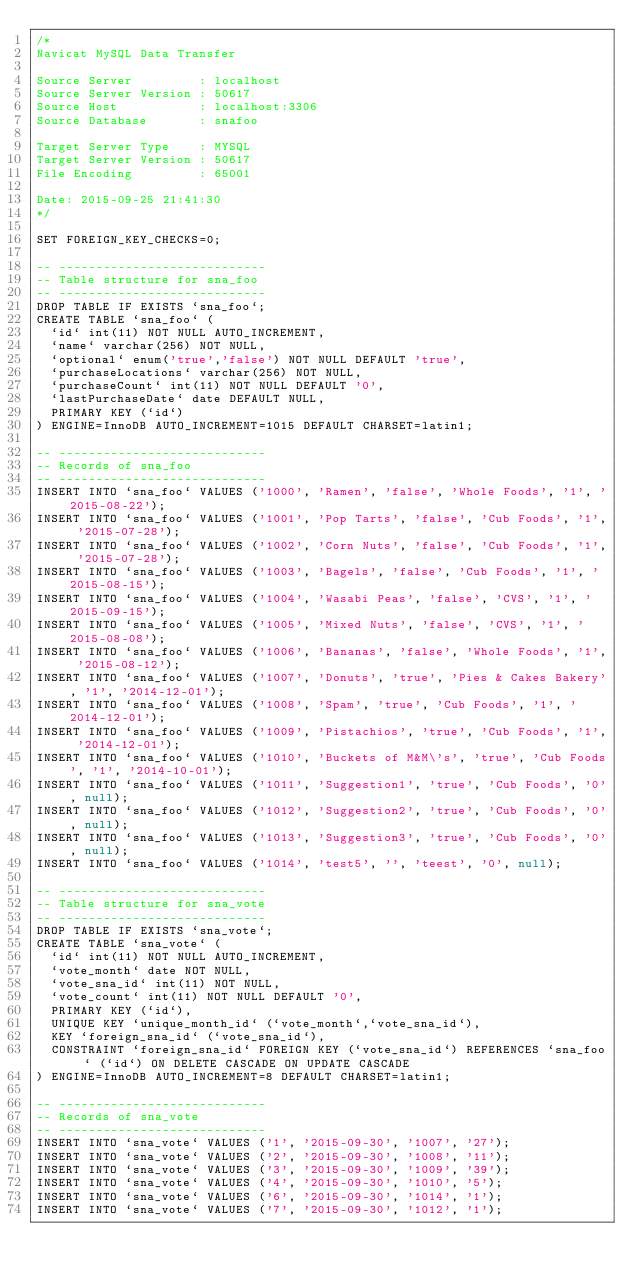Convert code to text. <code><loc_0><loc_0><loc_500><loc_500><_SQL_>/*
Navicat MySQL Data Transfer

Source Server         : localhost
Source Server Version : 50617
Source Host           : localhost:3306
Source Database       : snafoo

Target Server Type    : MYSQL
Target Server Version : 50617
File Encoding         : 65001

Date: 2015-09-25 21:41:30
*/

SET FOREIGN_KEY_CHECKS=0;

-- ----------------------------
-- Table structure for sna_foo
-- ----------------------------
DROP TABLE IF EXISTS `sna_foo`;
CREATE TABLE `sna_foo` (
  `id` int(11) NOT NULL AUTO_INCREMENT,
  `name` varchar(256) NOT NULL,
  `optional` enum('true','false') NOT NULL DEFAULT 'true',
  `purchaseLocations` varchar(256) NOT NULL,
  `purchaseCount` int(11) NOT NULL DEFAULT '0',
  `lastPurchaseDate` date DEFAULT NULL,
  PRIMARY KEY (`id`)
) ENGINE=InnoDB AUTO_INCREMENT=1015 DEFAULT CHARSET=latin1;

-- ----------------------------
-- Records of sna_foo
-- ----------------------------
INSERT INTO `sna_foo` VALUES ('1000', 'Ramen', 'false', 'Whole Foods', '1', '2015-08-22');
INSERT INTO `sna_foo` VALUES ('1001', 'Pop Tarts', 'false', 'Cub Foods', '1', '2015-07-28');
INSERT INTO `sna_foo` VALUES ('1002', 'Corn Nuts', 'false', 'Cub Foods', '1', '2015-07-28');
INSERT INTO `sna_foo` VALUES ('1003', 'Bagels', 'false', 'Cub Foods', '1', '2015-08-15');
INSERT INTO `sna_foo` VALUES ('1004', 'Wasabi Peas', 'false', 'CVS', '1', '2015-09-15');
INSERT INTO `sna_foo` VALUES ('1005', 'Mixed Nuts', 'false', 'CVS', '1', '2015-08-08');
INSERT INTO `sna_foo` VALUES ('1006', 'Bananas', 'false', 'Whole Foods', '1', '2015-08-12');
INSERT INTO `sna_foo` VALUES ('1007', 'Donuts', 'true', 'Pies & Cakes Bakery', '1', '2014-12-01');
INSERT INTO `sna_foo` VALUES ('1008', 'Spam', 'true', 'Cub Foods', '1', '2014-12-01');
INSERT INTO `sna_foo` VALUES ('1009', 'Pistachios', 'true', 'Cub Foods', '1', '2014-12-01');
INSERT INTO `sna_foo` VALUES ('1010', 'Buckets of M&M\'s', 'true', 'Cub Foods', '1', '2014-10-01');
INSERT INTO `sna_foo` VALUES ('1011', 'Suggestion1', 'true', 'Cub Foods', '0', null);
INSERT INTO `sna_foo` VALUES ('1012', 'Suggestion2', 'true', 'Cub Foods', '0', null);
INSERT INTO `sna_foo` VALUES ('1013', 'Suggestion3', 'true', 'Cub Foods', '0', null);
INSERT INTO `sna_foo` VALUES ('1014', 'test5', '', 'teest', '0', null);

-- ----------------------------
-- Table structure for sna_vote
-- ----------------------------
DROP TABLE IF EXISTS `sna_vote`;
CREATE TABLE `sna_vote` (
  `id` int(11) NOT NULL AUTO_INCREMENT,
  `vote_month` date NOT NULL,
  `vote_sna_id` int(11) NOT NULL,
  `vote_count` int(11) NOT NULL DEFAULT '0',
  PRIMARY KEY (`id`),
  UNIQUE KEY `unique_month_id` (`vote_month`,`vote_sna_id`),
  KEY `foreign_sna_id` (`vote_sna_id`),
  CONSTRAINT `foreign_sna_id` FOREIGN KEY (`vote_sna_id`) REFERENCES `sna_foo` (`id`) ON DELETE CASCADE ON UPDATE CASCADE
) ENGINE=InnoDB AUTO_INCREMENT=8 DEFAULT CHARSET=latin1;

-- ----------------------------
-- Records of sna_vote
-- ----------------------------
INSERT INTO `sna_vote` VALUES ('1', '2015-09-30', '1007', '27');
INSERT INTO `sna_vote` VALUES ('2', '2015-09-30', '1008', '11');
INSERT INTO `sna_vote` VALUES ('3', '2015-09-30', '1009', '39');
INSERT INTO `sna_vote` VALUES ('4', '2015-09-30', '1010', '5');
INSERT INTO `sna_vote` VALUES ('6', '2015-09-30', '1014', '1');
INSERT INTO `sna_vote` VALUES ('7', '2015-09-30', '1012', '1');
</code> 